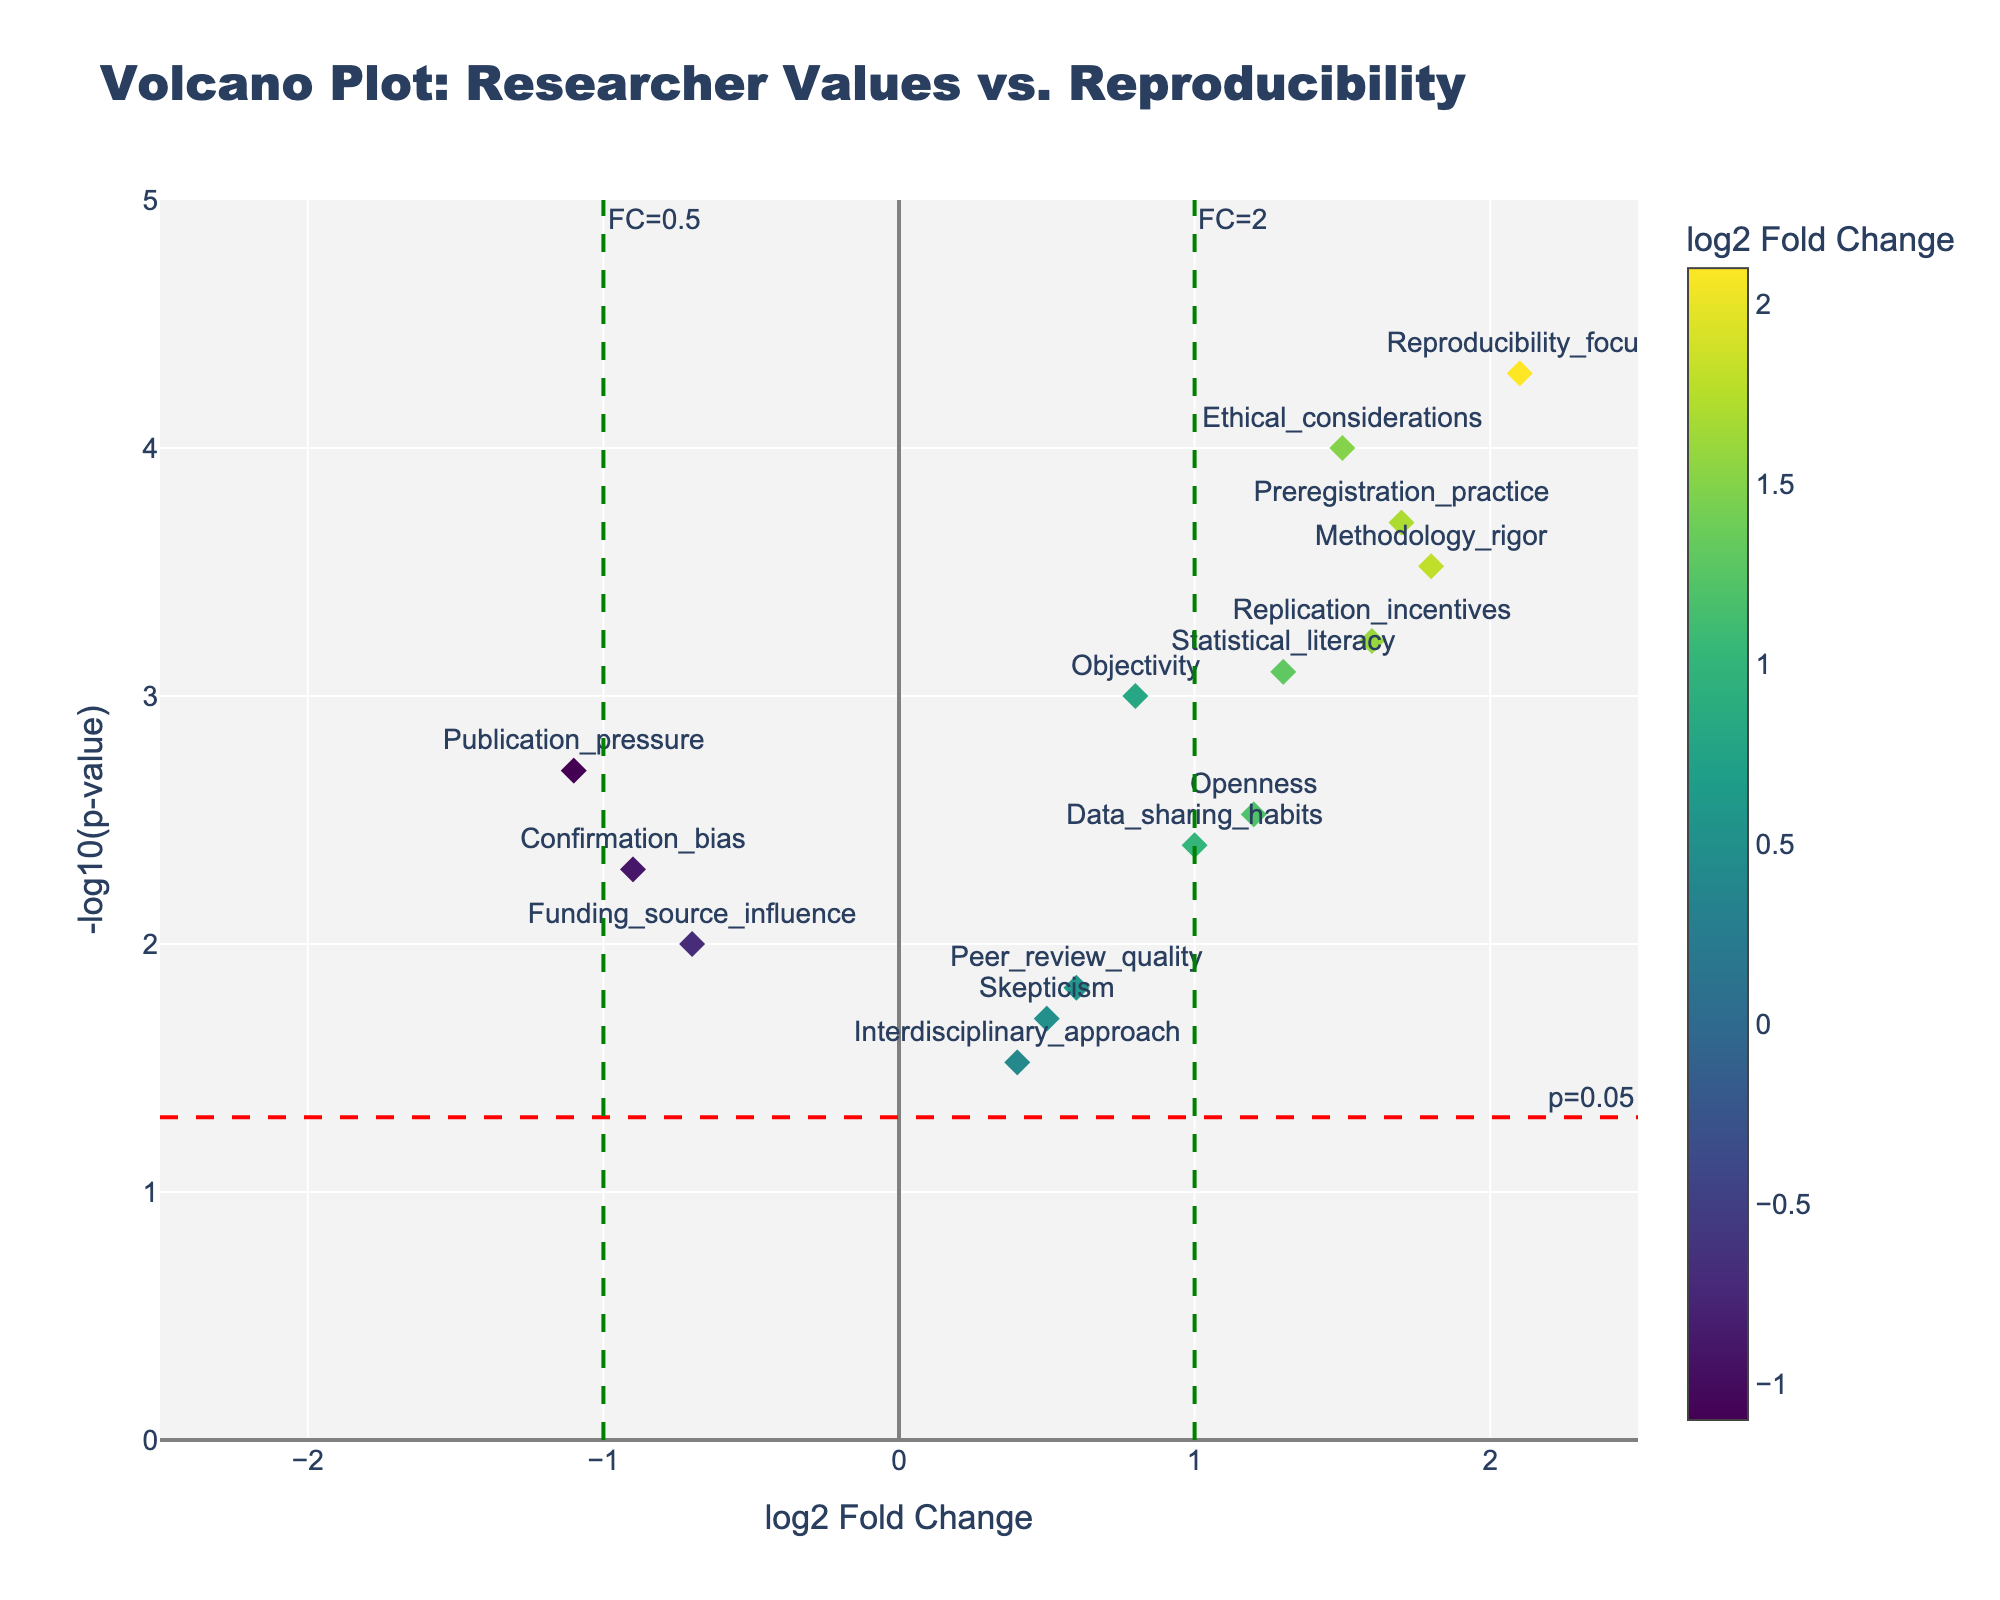what is the title of the plot? The title is usually displayed at the top of the plot. In this case, it reads "Volcano Plot: Researcher Values vs. Reproducibility."
Answer: Volcano Plot: Researcher Values vs. Reproducibility How many researcher values have a log2 fold change greater than 1? Check the x-axis for values greater than 1 and count the corresponding data points. The values are: "Openness," "Ethical_considerations," "Methodology_rigor," "Reproducibility_focus," and "Preregistration_practice," "Statistical_literacy," "Replication_incentives," and "Data_sharing_habits."
Answer: 8 Which researcher value has the highest -log10(p-value)? Look for the data point with the highest y-axis value, corresponding to the lowest p-value. This is "Reproducibility_focus."
Answer: Reproducibility_focus What are the colors used to represent the log2 fold changes, and what do they signify? The color scale is shown as a color bar, labeled "log2 Fold Change," with colors ranging from light to dark indicating different magnitudes of fold changes.
Answer: A color scale from light to dark Which researcher values have a p-value less than 0.01? Identify the values where the y-axis value exceeds -log10(0.01), approximately 2 on this plot. The corresponding values are "Objectivity," "Openness," "Confirmation_bias," "Ethical_considerations," "Publication_pressure," "Reproducibility_focus," "Methodology_rigor," "Peer_review_quality," "Statistical_literacy," "Preregistration_practice," "Data_sharing_habits," and "Replication_incentives."
Answer: 12 What is the log2 fold change and p-value of "Confirmation_bias"? Hover over the point labeled "Confirmation_bias" to see its hover text: log2 FC: -0.9 and p-value: 0.005.
Answer: log2 FC: -0.9, p-value: 0.005 Which value contributes most positively to reproducibility rates? Look for the data point with the maximum positive fold change. This is "Reproducibility_focus" with the highest positive log2 fold change of 2.1.
Answer: Reproducibility_focus How does "Publication_pressure" compare to "Ethical_considerations"? Compare the log2 fold change and -log10(p-value) for both. "Publication_pressure" has a negative log2 fold change (-1.1) and higher p-value, while "Ethical_considerations" has a highly significant positive log2 fold change (1.5).
Answer: "Ethical_considerations" has a higher positive impact and lower p-value than "Publication_pressure." How many values have a log2 fold change less than -1? Check the x-axis for values less than -1 and count the corresponding data points. Only "Publication_pressure" falls in this range.
Answer: 1 Which values are closest to the significance threshold of p=0.05? Check the points around the red dashed line at -log10(p-value) = 1.3 and identify the closest on either side. These values are "Skepticism" and "Interdisciplinary_approach."
Answer: Skepticism, Interdisciplinary_approach 